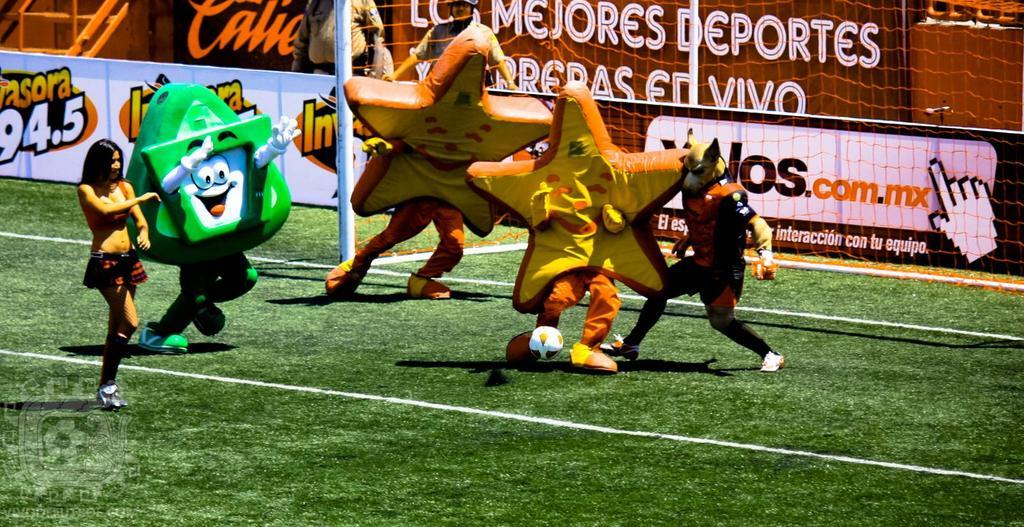Who or what is present in the image? There are people in the image. What are the people wearing? The people are wearing costumes. What type of surface can be seen in the image? There is ground visible in the image. What structure is present in the image? There is a pole in the image. What material is visible in the image? There is mesh in the image. What type of signage is present in the image? There are hoardings in the image. Can you describe the unspecified object in the image? Unfortunately, the facts provided do not specify the nature of the unspecified object. How many feet are visible on the giants in the image? There are no giants present in the image, so there are no visible feet to count. What type of sport is being played by the people in the image? The facts provided do not mention any sport being played in the image, so it cannot be determined from the information given. 